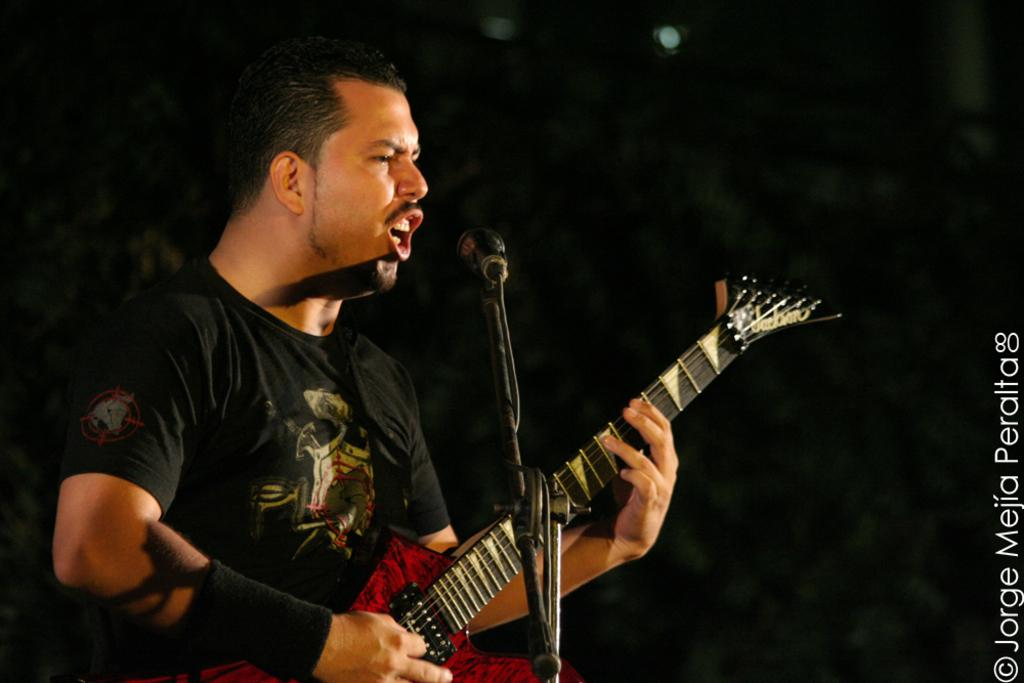What is the man in the image doing? The man is holding a guitar and singing into a microphone. What object is the man holding in the image? The man is holding a guitar. Can you describe the lighting in the image? There is a light in the background of the image. How would you describe the overall appearance of the image? The image appears to be dark. What type of cheese is being used as a prop in the image? There is no cheese present in the image. How many cattle can be seen grazing in the background of the image? There are no cattle visible in the image; it features a man holding a guitar and singing into a microphone. 